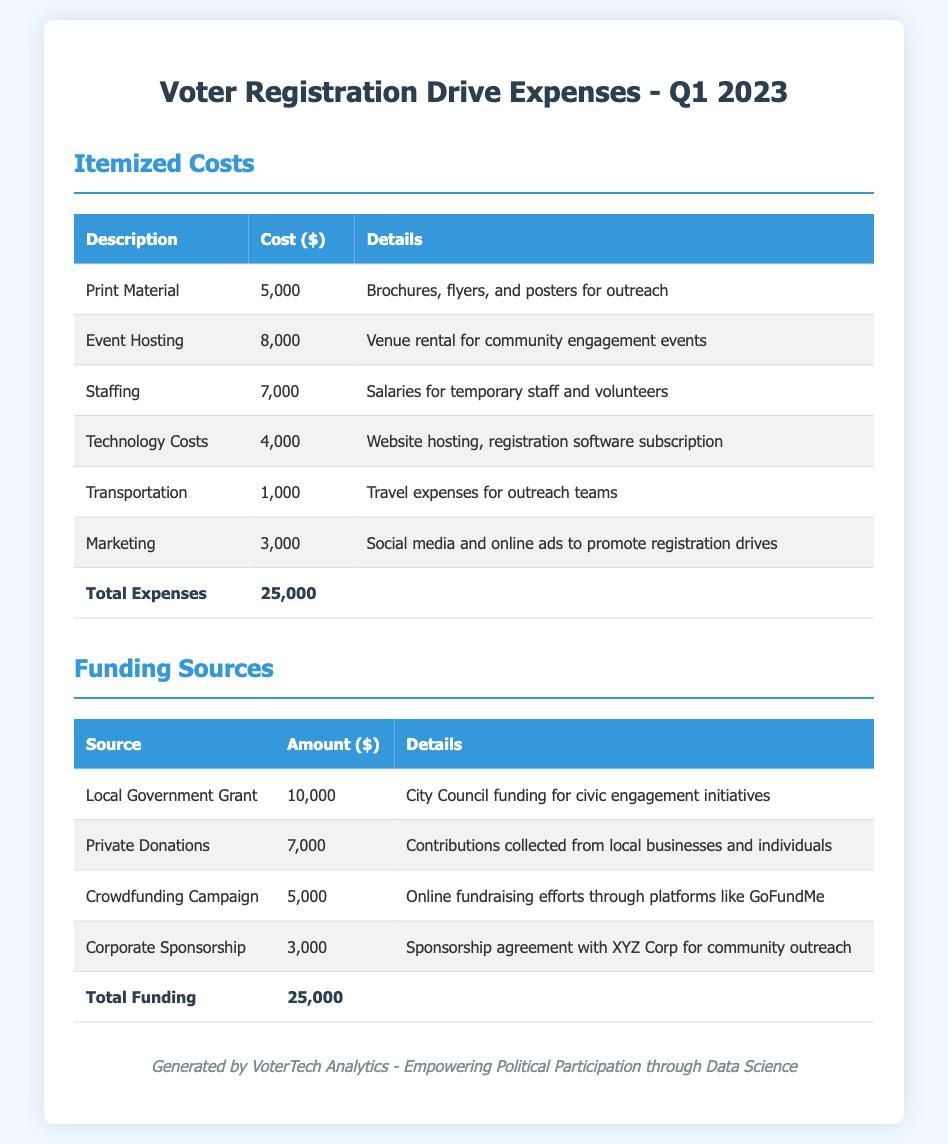what is the total cost of print material? The cost of print material is listed under the itemized costs section, which is $5000.
Answer: $5000 what is the amount received from private donations? The amount received from private donations is provided under the funding sources section, which is $7000.
Answer: $7000 how much was spent on event hosting? The amount spent on event hosting can be found in the itemized costs table, which is $8000.
Answer: $8000 what is the total amount of funding? The total amount of funding is noted in the funding sources table as $25000.
Answer: $25000 which organization provided corporate sponsorship? The funding source for corporate sponsorship is specified as XYZ Corp.
Answer: XYZ Corp what was the lowest individual expense item? The lowest individual expense item listed is transportation, costing $1000.
Answer: $1000 what percentage of total expenses was spent on staffing? Staffing cost of $7000 makes up 28% of the total expenses of $25000.
Answer: 28% which funding source contributed the highest amount? The highest contributing funding source is the local government grant at $10000.
Answer: Local Government Grant how many total expenses are listed in the document? The total number of expense items listed in the document is six.
Answer: Six 